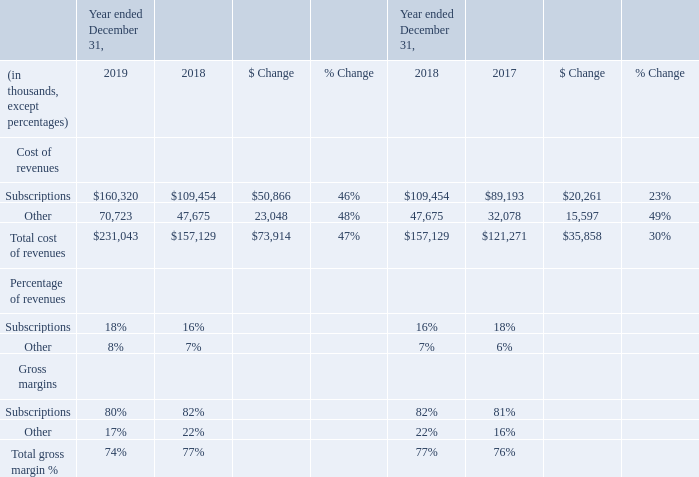Cost of Revenues and Gross Margin
Subscription cost of revenues and gross margin. Cost of subscriptions revenues increased by $50.9 million, or 46%, during fiscal year 2019 as compared to fiscal year 2018. Primary drivers of the increase were increases in third-party costs to support our solution offerings of $21.5 million, infrastructure support costs of $19.8 million including amortization expense from acquired intangible assets, and headcount and personnel and contractor related costs of $9.6 million including share-based compensation expense. These factors resulted in a decrease in gross margin.
The increase in headcount and other expense categories described herein was driven primarily by investments in our infrastructure and capacity to improve the availability of our subscription offerings, while also supporting the growth in new customers and increased usage of our subscriptions by our existing customer base. We expect subscription gross margin to be within a relatively similar range in the future.
Other cost of revenues and gross margin. Cost of other revenues increased by $23.0 million, or 48%, during fiscal year 2019 as compared to fiscal year 2018. This was primarily due to the increase in services personnel costs of $11.1 million including share-based compensation expense, cost of product sales of $10.6 million, and overhead costs of $1.3 million. Other revenues gross margin fluctuates based on timing of completion of professional services projects and discounting on phones.
What are the respective drivers of the company's increased cost of revenue in 2019? Third-party costs to support our solution offerings, infrastructure support costs, headcount and personnel and contractor related costs. What caused the increased in headcount and other expense? Investments in our infrastructure and capacity to improve the availability of our subscription offerings, while also supporting the growth in new customers and increased usage of our subscriptions by our existing customer base. What are the factors influencing the cost of revenues and gross margins in 2019? Increase in services personnel costs, cost of product sales, overhead costs. What is the average cost of subscription between 2017 to 2019?
Answer scale should be: thousand. (89,193 + 109,454 + 160,320)/3 
Answer: 119655.67. What is the value of the subscription costs as a percentage of the total cost of revenue in 2019?
Answer scale should be: percent. 160,320/231,043 
Answer: 69.39. What is the average total cost of revenue between 2017 to 2019?
Answer scale should be: thousand. (121,271 + 157,129 + 231,043)/3 
Answer: 169814.33. 